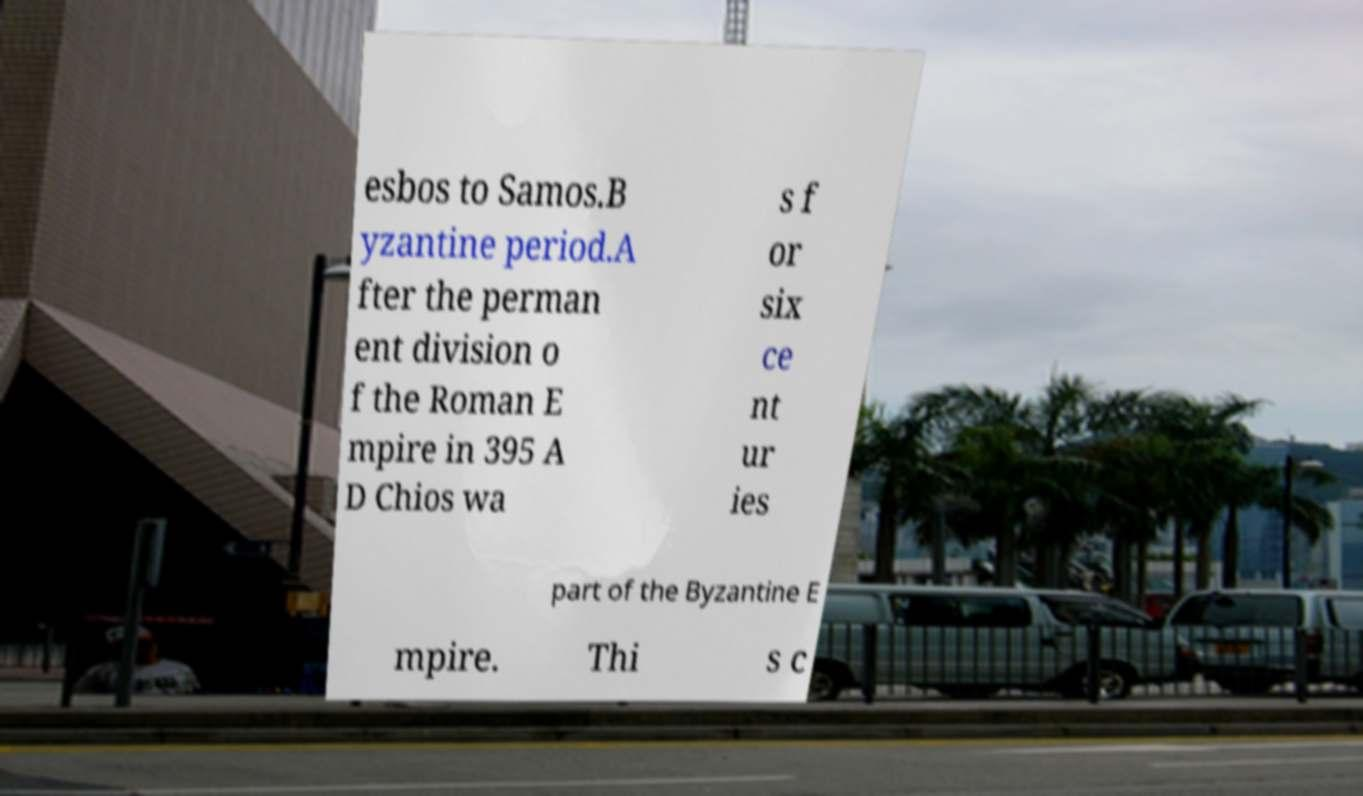For documentation purposes, I need the text within this image transcribed. Could you provide that? esbos to Samos.B yzantine period.A fter the perman ent division o f the Roman E mpire in 395 A D Chios wa s f or six ce nt ur ies part of the Byzantine E mpire. Thi s c 